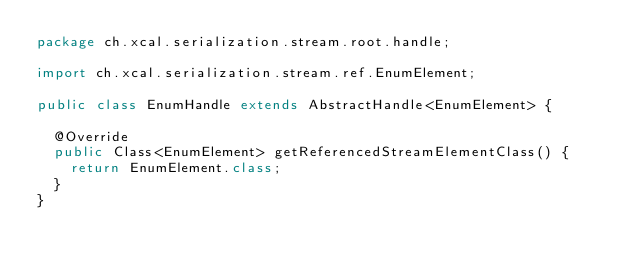Convert code to text. <code><loc_0><loc_0><loc_500><loc_500><_Java_>package ch.xcal.serialization.stream.root.handle;

import ch.xcal.serialization.stream.ref.EnumElement;

public class EnumHandle extends AbstractHandle<EnumElement> {

	@Override
	public Class<EnumElement> getReferencedStreamElementClass() {
		return EnumElement.class;
	}
}
</code> 